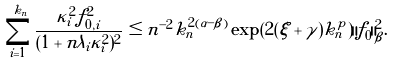<formula> <loc_0><loc_0><loc_500><loc_500>\sum _ { i = 1 } ^ { k _ { n } } \frac { \kappa _ { i } ^ { 2 } f _ { 0 , i } ^ { 2 } } { ( 1 + n \lambda _ { i } \kappa _ { i } ^ { 2 } ) ^ { 2 } } \leq n ^ { - 2 } k _ { n } ^ { 2 ( \alpha - \beta ) } \exp ( 2 ( \xi + \gamma ) k _ { n } ^ { p } ) \| f _ { 0 } \| ^ { 2 } _ { \beta } .</formula> 